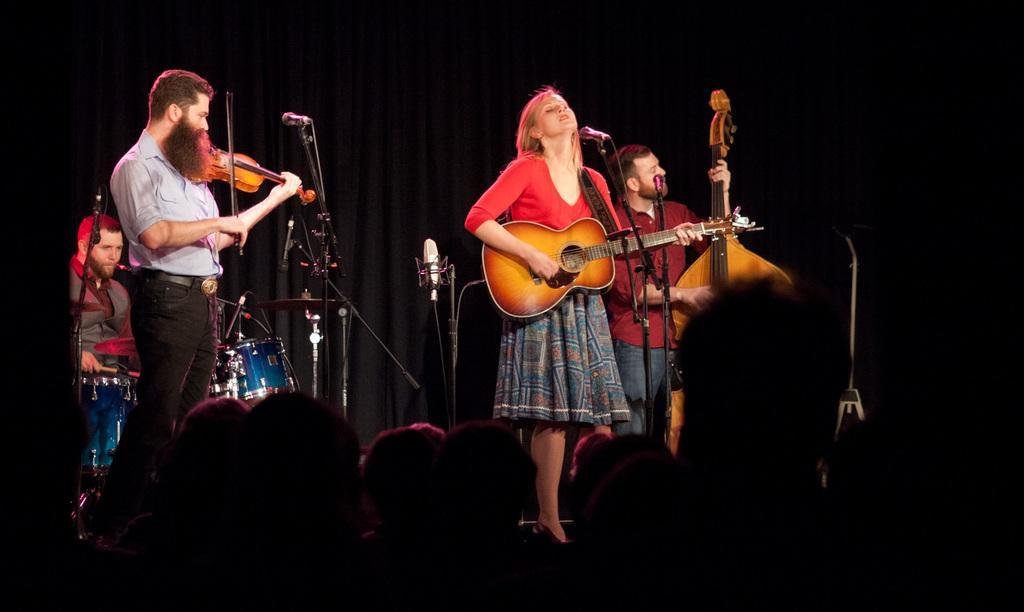In one or two sentences, can you explain what this image depicts? This image is clicked in a concert. There are four persons on the dais. In the middle the woman wearing red top and blue skirt is playing guitar. To the right, the man wearing red shirt is playing violin. At the background there is a black curtain. In the front there is crowd and the hall looks dark. 